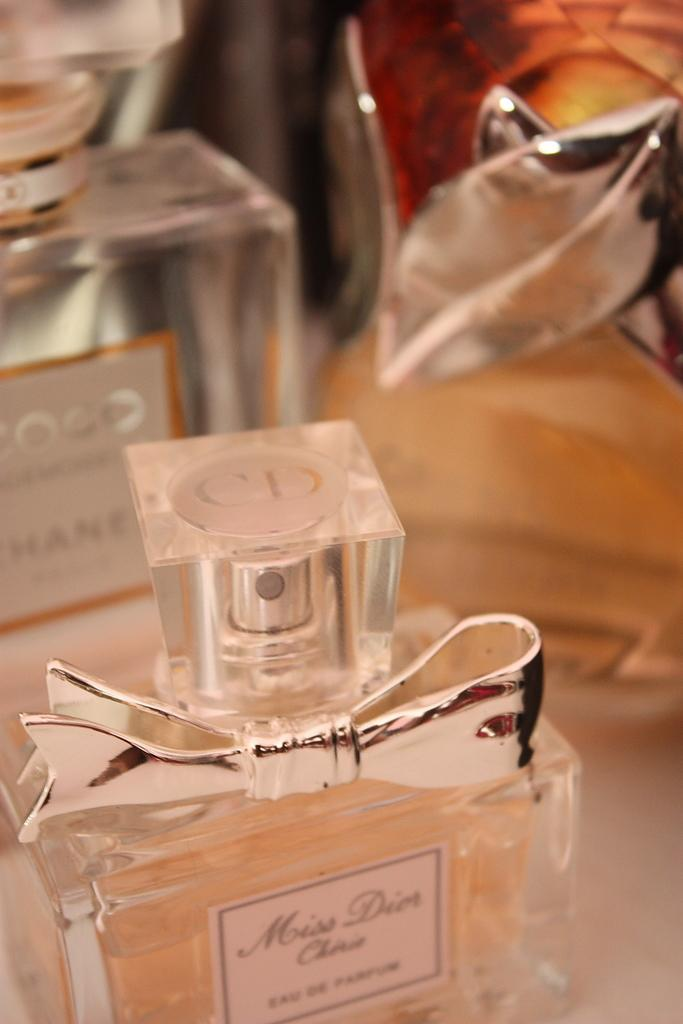Provide a one-sentence caption for the provided image. several perfume bottles, one is coco chanel and front one is miss dior. 